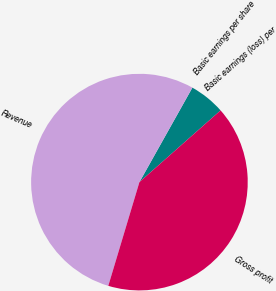Convert chart to OTSL. <chart><loc_0><loc_0><loc_500><loc_500><pie_chart><fcel>Basic earnings per share<fcel>Revenue<fcel>Gross profit<fcel>Basic earnings (loss) per<nl><fcel>5.35%<fcel>53.49%<fcel>41.16%<fcel>0.0%<nl></chart> 